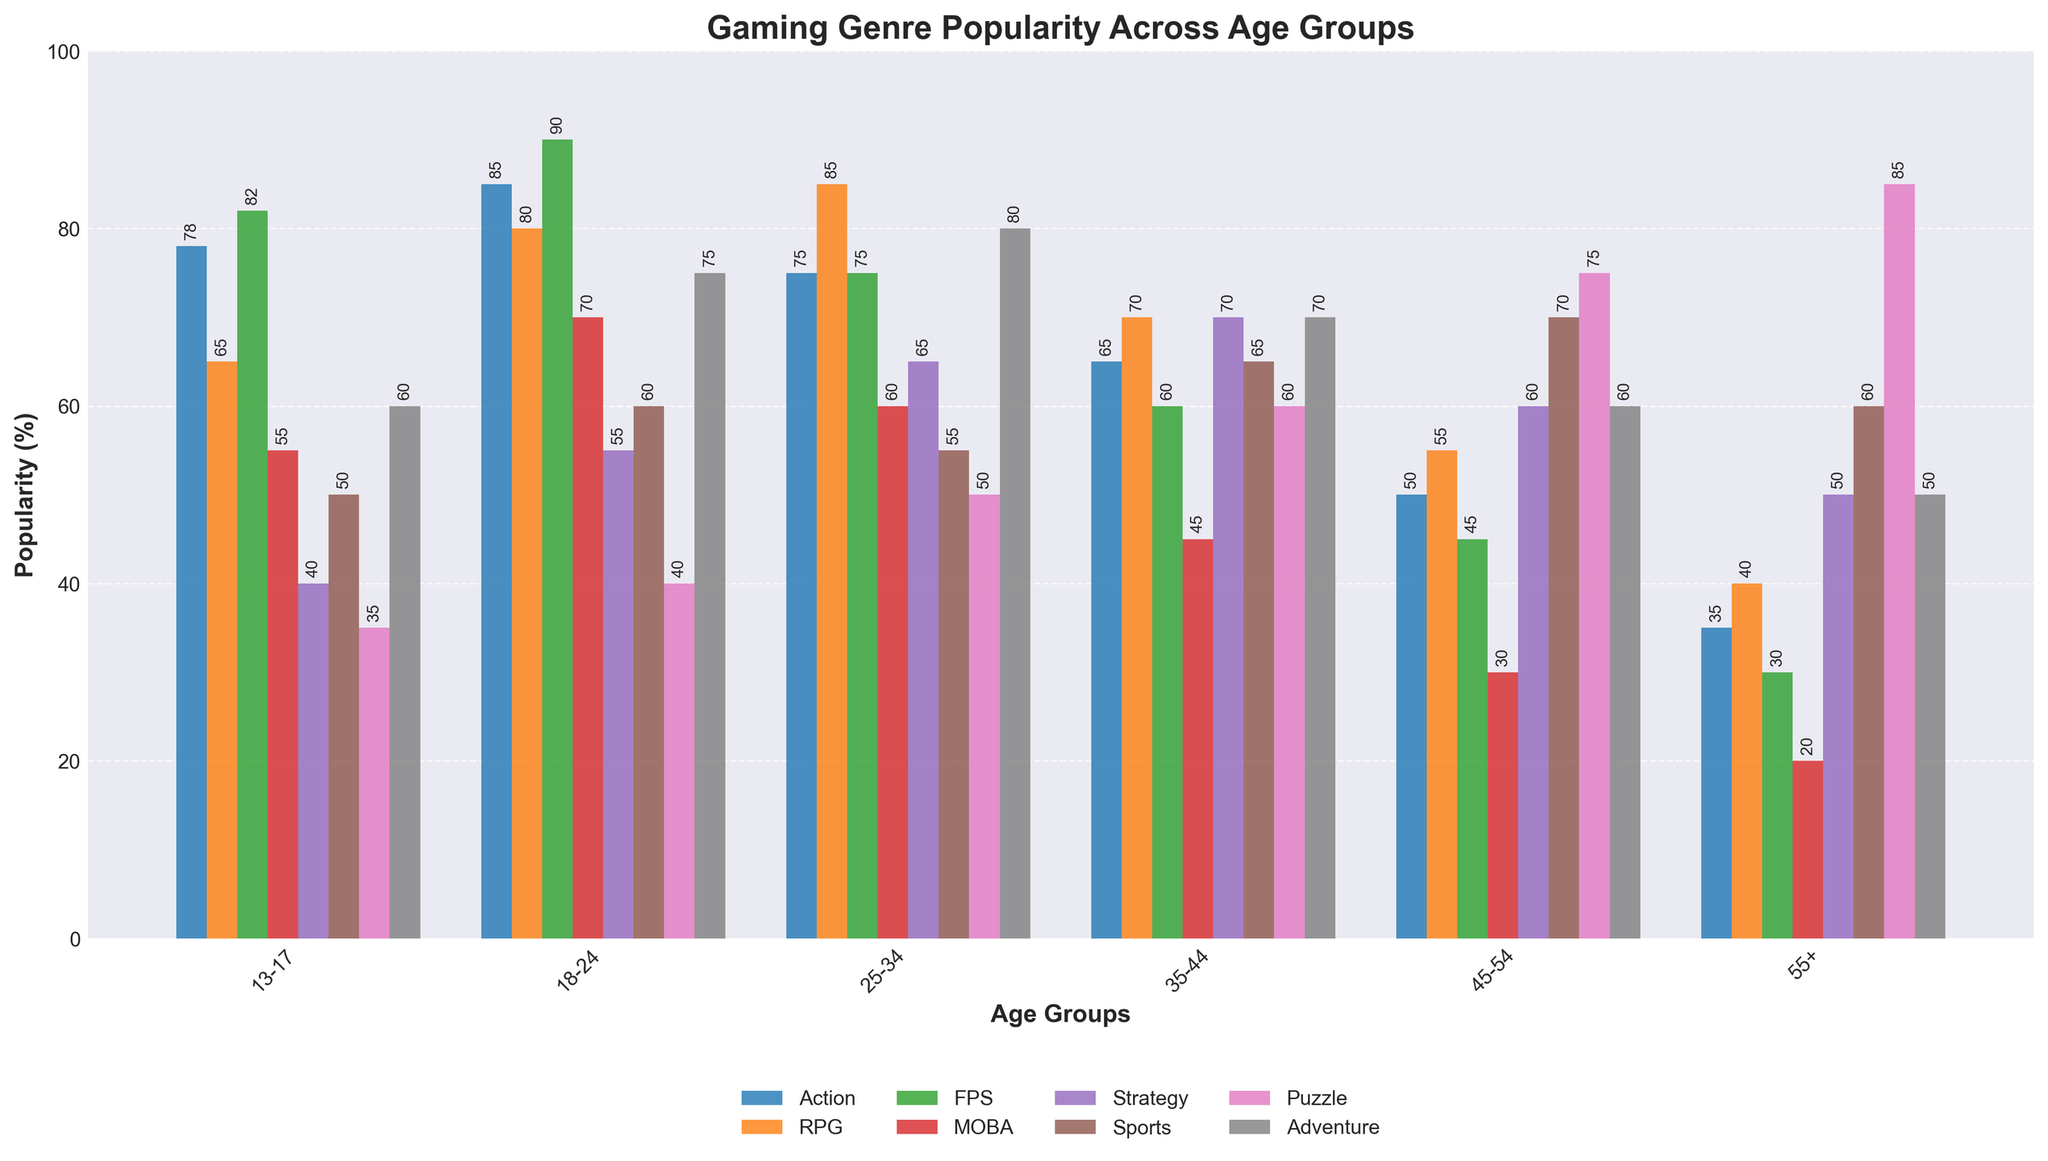What's the most popular gaming genre for the age group 18-24? The most popular genre for the age group 18-24 is the one with the highest bar. According to the chart, FPS has the tallest bar at 90%.
Answer: FPS Which age group prefers Puzzle games the most? To find the age group that prefers Puzzle games the most, we identify which bar is the tallest in the Puzzle category. The tallest bar is for the age group 55+, with a height of 85%.
Answer: 55+ Compare the popularity of RPG and MOBA for the age group 25-34. Which one is more popular and by how much? By looking at the bars for the age group 25-34, the RPG bar is at 85% and the MOBA bar is at 60%. The difference between them is 85% - 60% = 25%. RPG is more popular by 25%.
Answer: RPG by 25% Which genre has the least variability in popularity across all age groups? To determine the genre with the least variability, we need to find the genre whose bars are most similar in height across all age groups. Sports bars have values (50, 60, 55, 65, 70, 60), showing the smallest differences across age groups.
Answer: Sports What's the overall trend in popularity for Adventure games from the youngest to the oldest age group? By examining the bars for Adventure games: 60 (13-17), 75 (18-24), 80 (25-34), 70 (35-44), 60 (45-54), and 50 (55+). The trend shows an increase from 13-17 to 25-34, then a decrease from 35-44 to 55+.
Answer: Increase then decrease What's the sum of the popularity percentages of Action and FPS games for the 35-44 age group? For the age group 35-44, the popularity of Action is 65%, and FPS is 60%. Adding these together gives 65 + 60 = 125%.
Answer: 125% How does the popularity of Sports games change as age increases from 13-17 to 55+? Looking at each age group's bar for Sports games: 50 (13-17), 60 (18-24), 55 (25-34), 65 (35-44), 70 (45-54), and 60 (55+), there is an overall increase, with a slight drop only when moving from 45-54 to 55+.
Answer: Mostly increase Is the popularity of FPS games for the age group 18-24 greater than the combined popularity of MOBA and Puzzle for the same age group? For 18-24, FPS is 90%, MOBA is 70%, and Puzzle is 40%. The combined popularity of MOBA and Puzzle is 70 + 40 = 110%. 90% (FPS) is less than 110% (MOBA + Puzzle).
Answer: No Which age group has the lowest preference for MOBA games? By looking at the bars for MOBA games across all age groups: 55+, with a value of 20%, has the lowest bar.
Answer: 55+ 